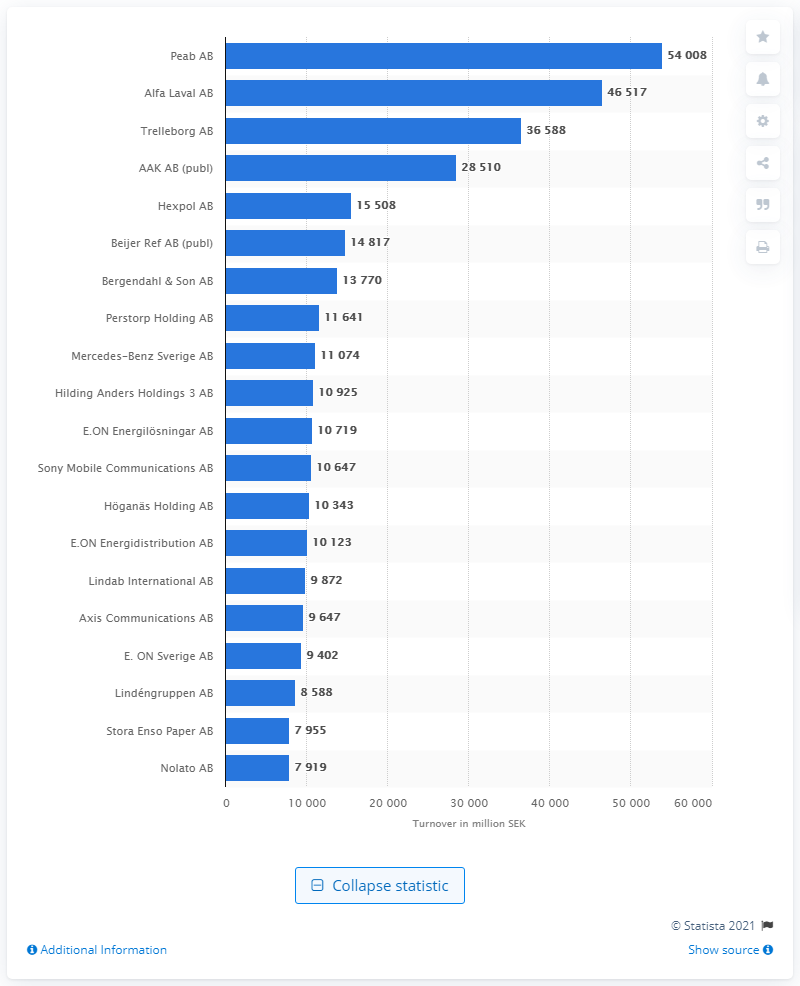Highlight a few significant elements in this photo. Peab AB was the company with the highest turnover in the Swedish county of Skne during the specified time period. Alfa Laval AB was the second largest company in terms of turnover in Sweden during a certain period. Peab AB reported a turnover of 54008 Swedish kronor. 